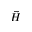<formula> <loc_0><loc_0><loc_500><loc_500>\vec { H }</formula> 